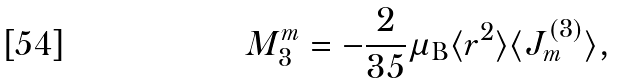Convert formula to latex. <formula><loc_0><loc_0><loc_500><loc_500>M ^ { m } _ { 3 } = - \frac { 2 } { 3 5 } \mu _ { \text {B} } \langle r ^ { 2 } \rangle \langle J ^ { ( 3 ) } _ { m } \rangle ,</formula> 